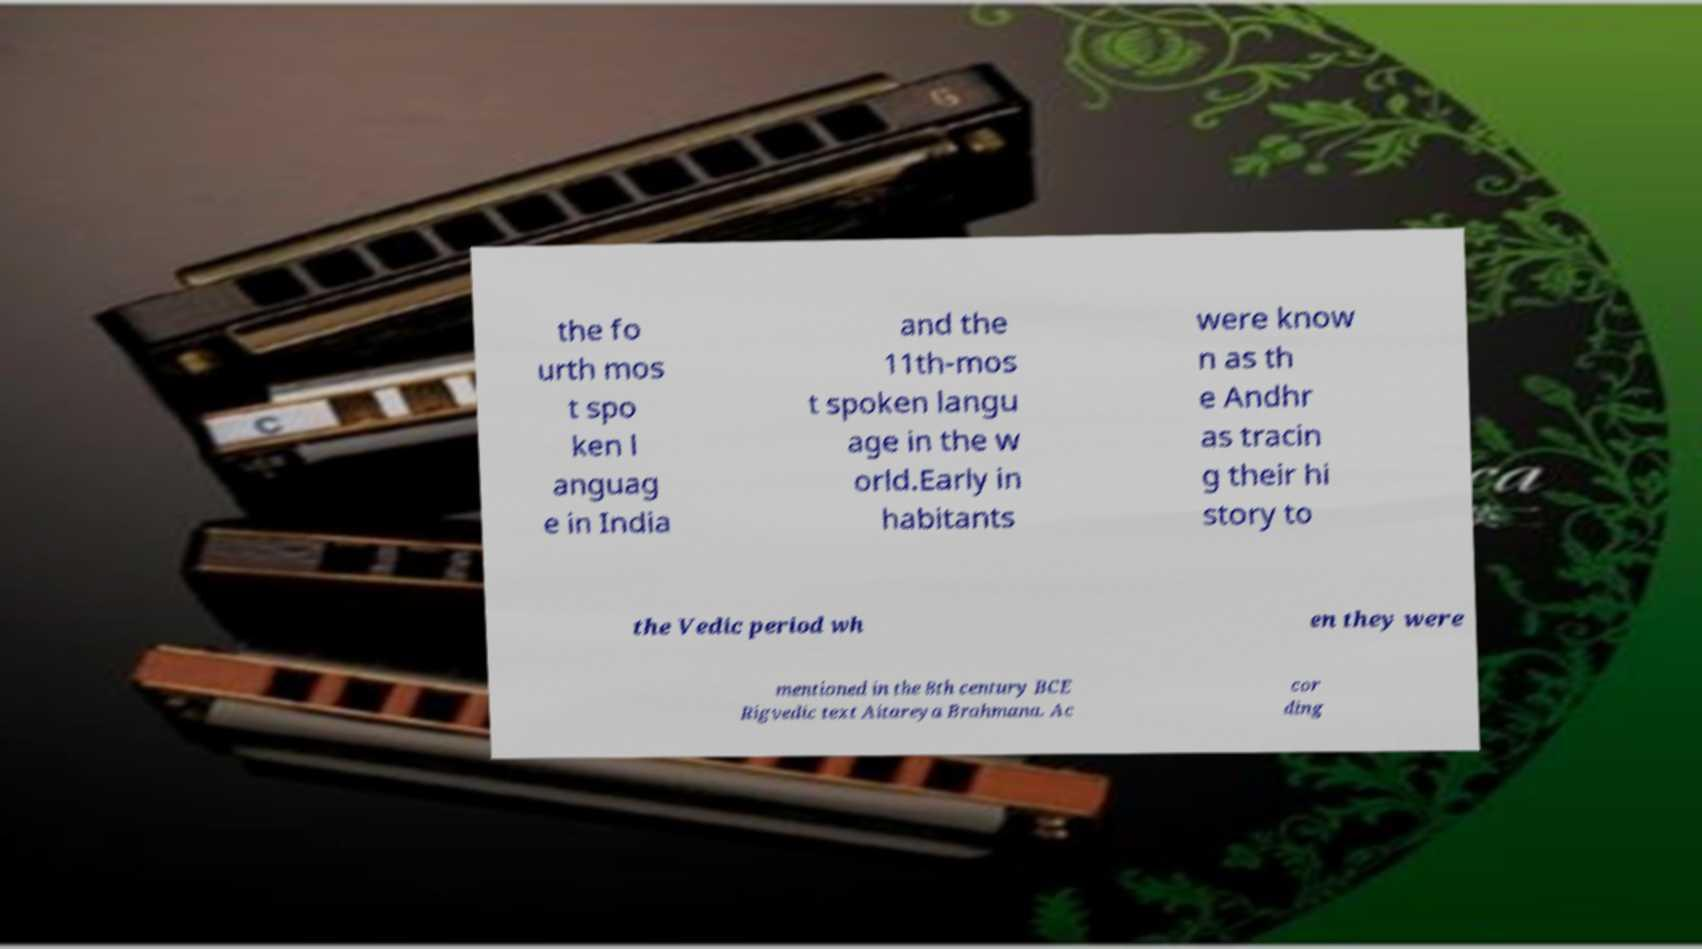What messages or text are displayed in this image? I need them in a readable, typed format. the fo urth mos t spo ken l anguag e in India and the 11th-mos t spoken langu age in the w orld.Early in habitants were know n as th e Andhr as tracin g their hi story to the Vedic period wh en they were mentioned in the 8th century BCE Rigvedic text Aitareya Brahmana. Ac cor ding 